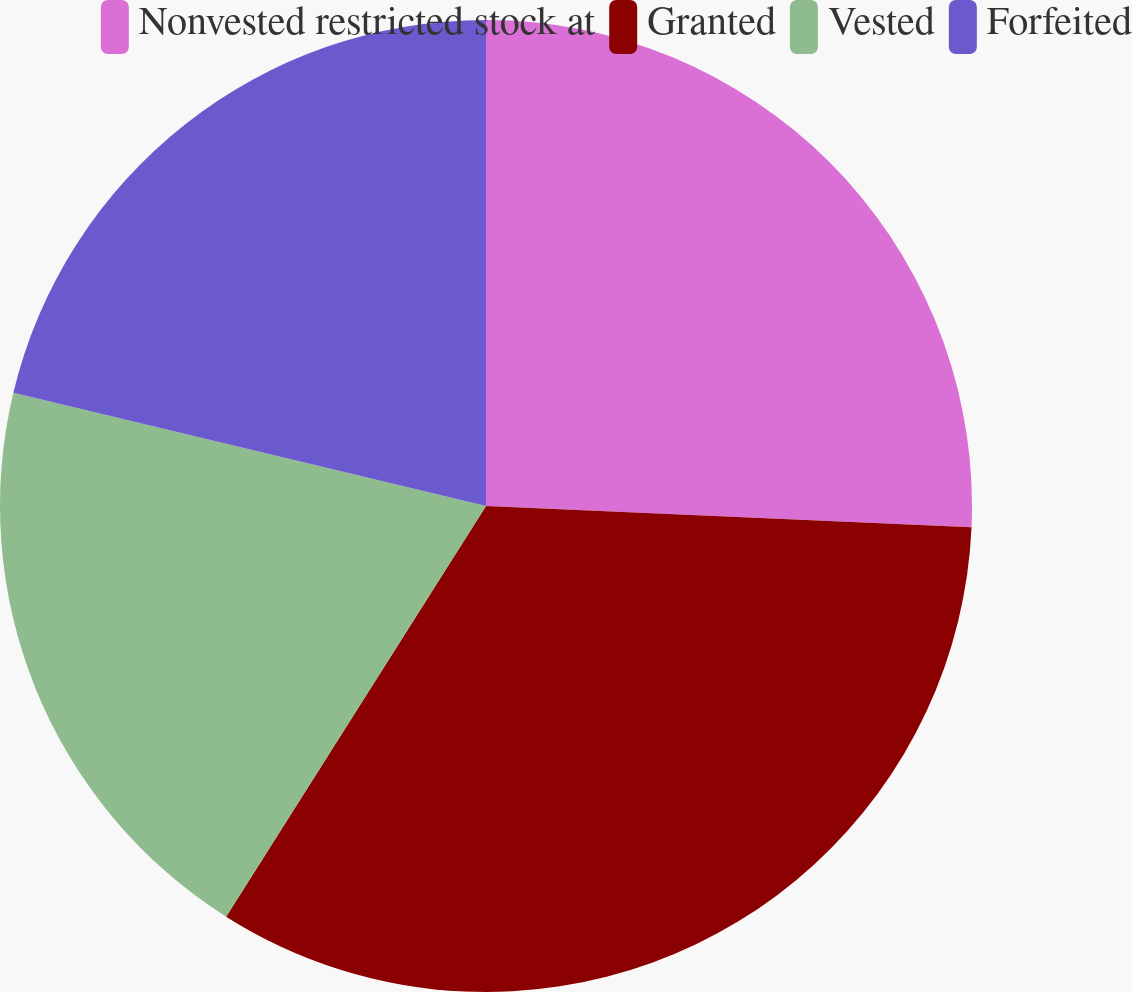Convert chart to OTSL. <chart><loc_0><loc_0><loc_500><loc_500><pie_chart><fcel>Nonvested restricted stock at<fcel>Granted<fcel>Vested<fcel>Forfeited<nl><fcel>25.7%<fcel>33.28%<fcel>19.76%<fcel>21.26%<nl></chart> 